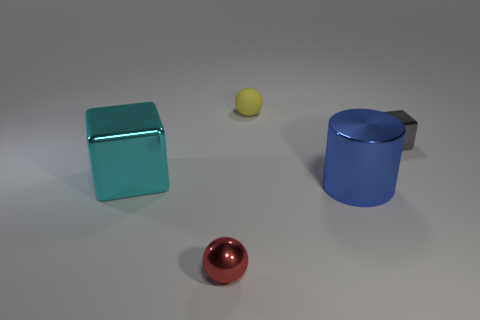What number of other things are the same size as the metal cylinder?
Give a very brief answer. 1. What material is the other thing that is the same shape as the tiny red shiny thing?
Offer a terse response. Rubber. What is the color of the large shiny cylinder?
Give a very brief answer. Blue. What is the color of the cube that is on the left side of the small thing that is behind the small cube?
Make the answer very short. Cyan. Do the rubber sphere and the metal block in front of the gray metallic object have the same color?
Your answer should be very brief. No. What number of blocks are behind the small metallic thing in front of the tiny thing on the right side of the small yellow rubber thing?
Offer a very short reply. 2. There is a large cylinder; are there any objects right of it?
Your answer should be compact. Yes. What number of spheres are gray things or blue metal things?
Provide a succinct answer. 0. How many metallic objects are left of the big blue metallic thing and behind the blue metallic cylinder?
Your answer should be compact. 1. Are there an equal number of red metal objects that are in front of the red object and large cubes on the left side of the blue cylinder?
Offer a terse response. No. 